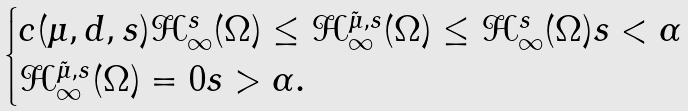<formula> <loc_0><loc_0><loc_500><loc_500>\begin{cases} c ( \mu , d , s ) \mathcal { H } ^ { s } _ { \infty } ( \Omega ) \leq \mathcal { H } ^ { \tilde { \mu } , s } _ { \infty } ( \Omega ) \leq \mathcal { H } ^ { s } _ { \infty } ( \Omega ) s < \alpha \\ \mathcal { H } ^ { \tilde { \mu } , s } _ { \infty } ( \Omega ) = 0 s > \alpha . \end{cases}</formula> 